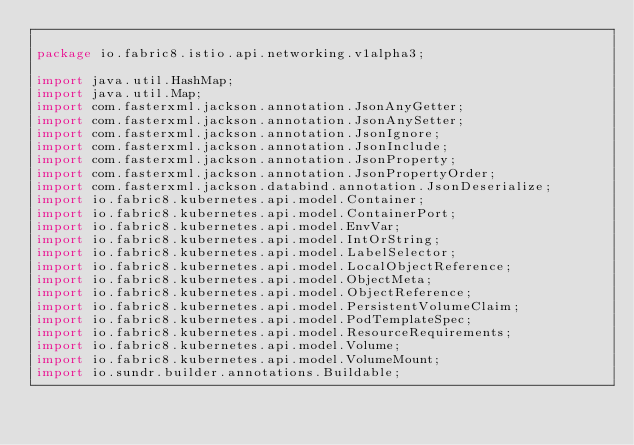Convert code to text. <code><loc_0><loc_0><loc_500><loc_500><_Java_>
package io.fabric8.istio.api.networking.v1alpha3;

import java.util.HashMap;
import java.util.Map;
import com.fasterxml.jackson.annotation.JsonAnyGetter;
import com.fasterxml.jackson.annotation.JsonAnySetter;
import com.fasterxml.jackson.annotation.JsonIgnore;
import com.fasterxml.jackson.annotation.JsonInclude;
import com.fasterxml.jackson.annotation.JsonProperty;
import com.fasterxml.jackson.annotation.JsonPropertyOrder;
import com.fasterxml.jackson.databind.annotation.JsonDeserialize;
import io.fabric8.kubernetes.api.model.Container;
import io.fabric8.kubernetes.api.model.ContainerPort;
import io.fabric8.kubernetes.api.model.EnvVar;
import io.fabric8.kubernetes.api.model.IntOrString;
import io.fabric8.kubernetes.api.model.LabelSelector;
import io.fabric8.kubernetes.api.model.LocalObjectReference;
import io.fabric8.kubernetes.api.model.ObjectMeta;
import io.fabric8.kubernetes.api.model.ObjectReference;
import io.fabric8.kubernetes.api.model.PersistentVolumeClaim;
import io.fabric8.kubernetes.api.model.PodTemplateSpec;
import io.fabric8.kubernetes.api.model.ResourceRequirements;
import io.fabric8.kubernetes.api.model.Volume;
import io.fabric8.kubernetes.api.model.VolumeMount;
import io.sundr.builder.annotations.Buildable;</code> 